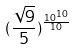<formula> <loc_0><loc_0><loc_500><loc_500>( \frac { \sqrt { 9 } } { 5 } ) ^ { \frac { 1 0 ^ { 1 0 } } { 1 0 } }</formula> 